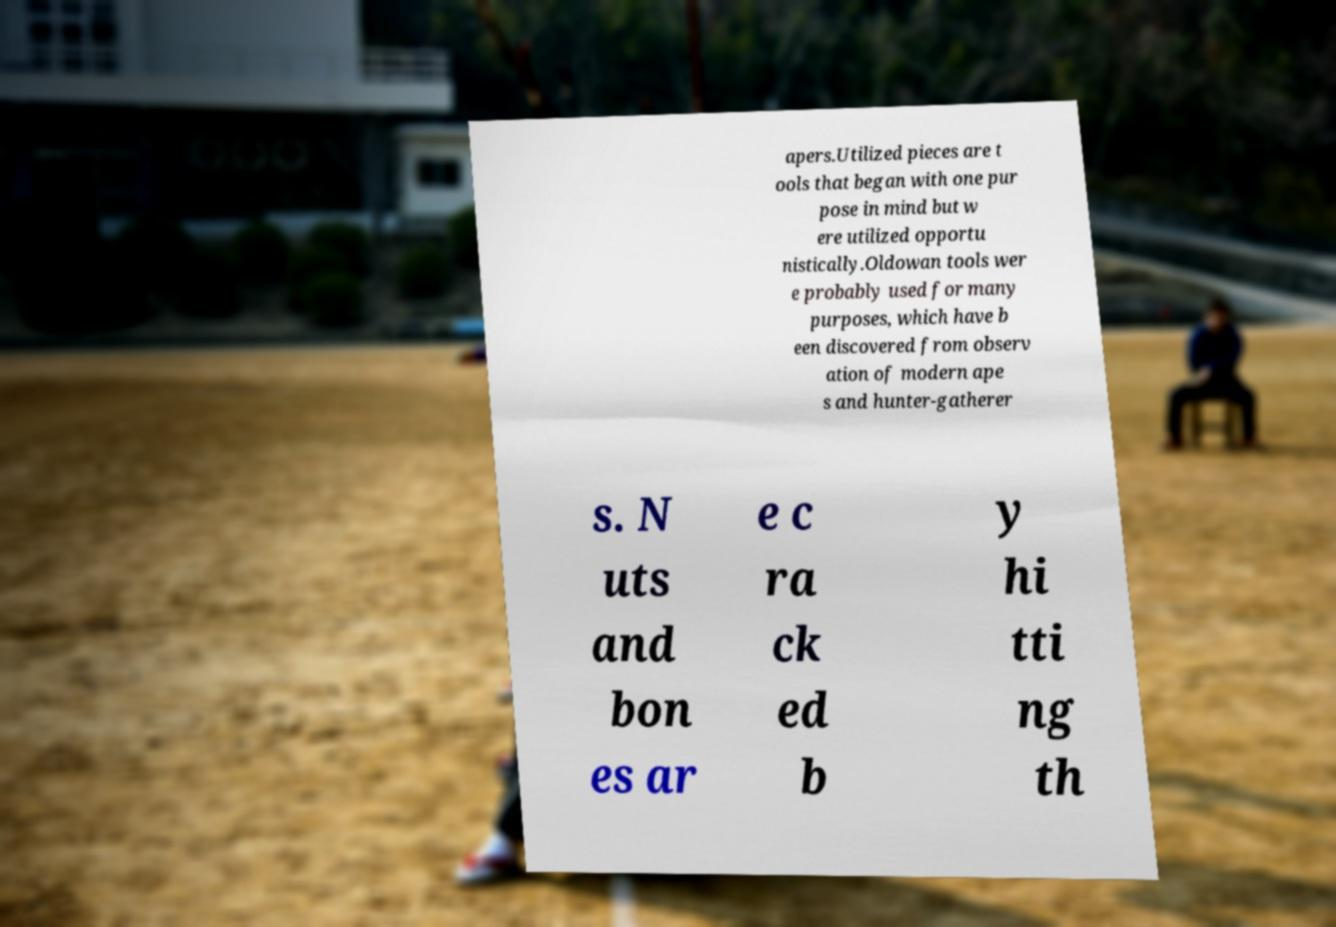What messages or text are displayed in this image? I need them in a readable, typed format. apers.Utilized pieces are t ools that began with one pur pose in mind but w ere utilized opportu nistically.Oldowan tools wer e probably used for many purposes, which have b een discovered from observ ation of modern ape s and hunter-gatherer s. N uts and bon es ar e c ra ck ed b y hi tti ng th 